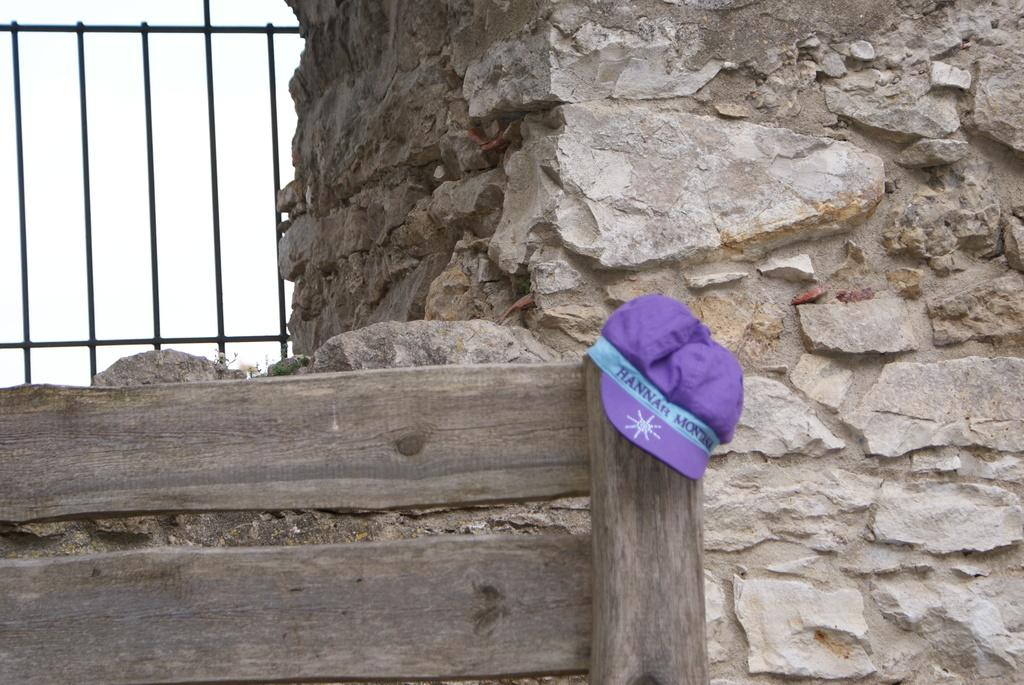What type of structure is visible in the image? There is a rock wall in the image. What is placed on top of the wood? There is a cap on the wood. Where are the grills located in the image? The grills are in the top left of the image. What type of chair is placed next to the bed in the image? There is no chair or bed present in the image; it only features a rock wall, a cap on the wood, and grills in the top left. 